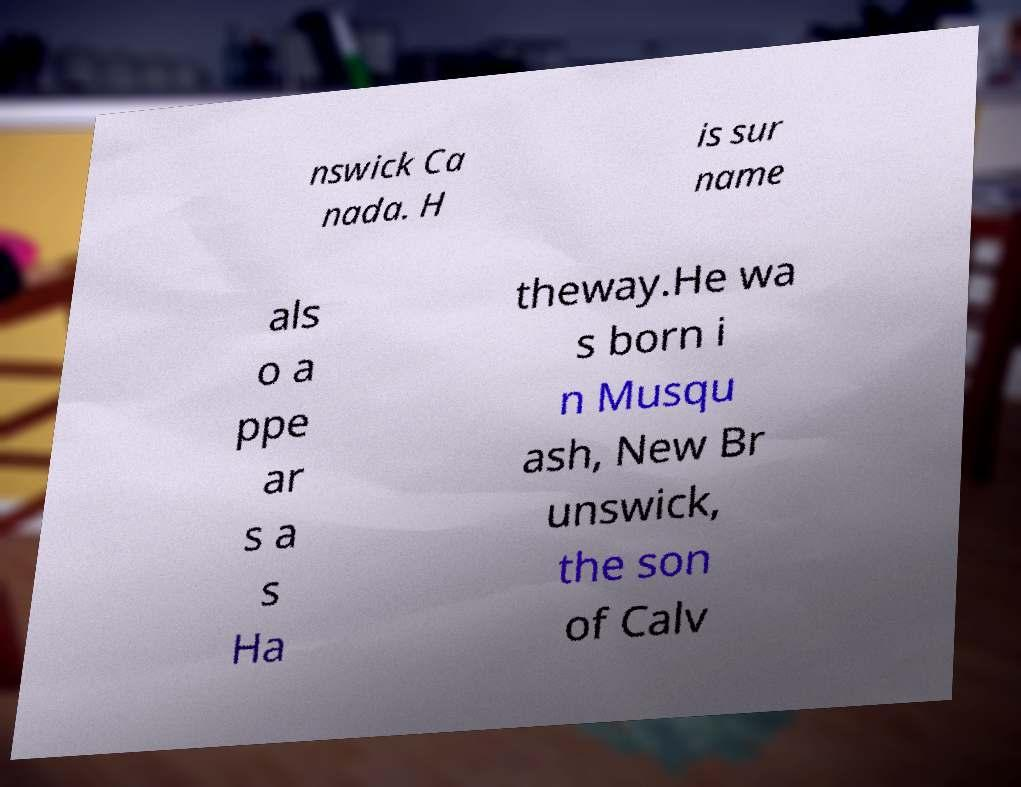Could you assist in decoding the text presented in this image and type it out clearly? nswick Ca nada. H is sur name als o a ppe ar s a s Ha theway.He wa s born i n Musqu ash, New Br unswick, the son of Calv 